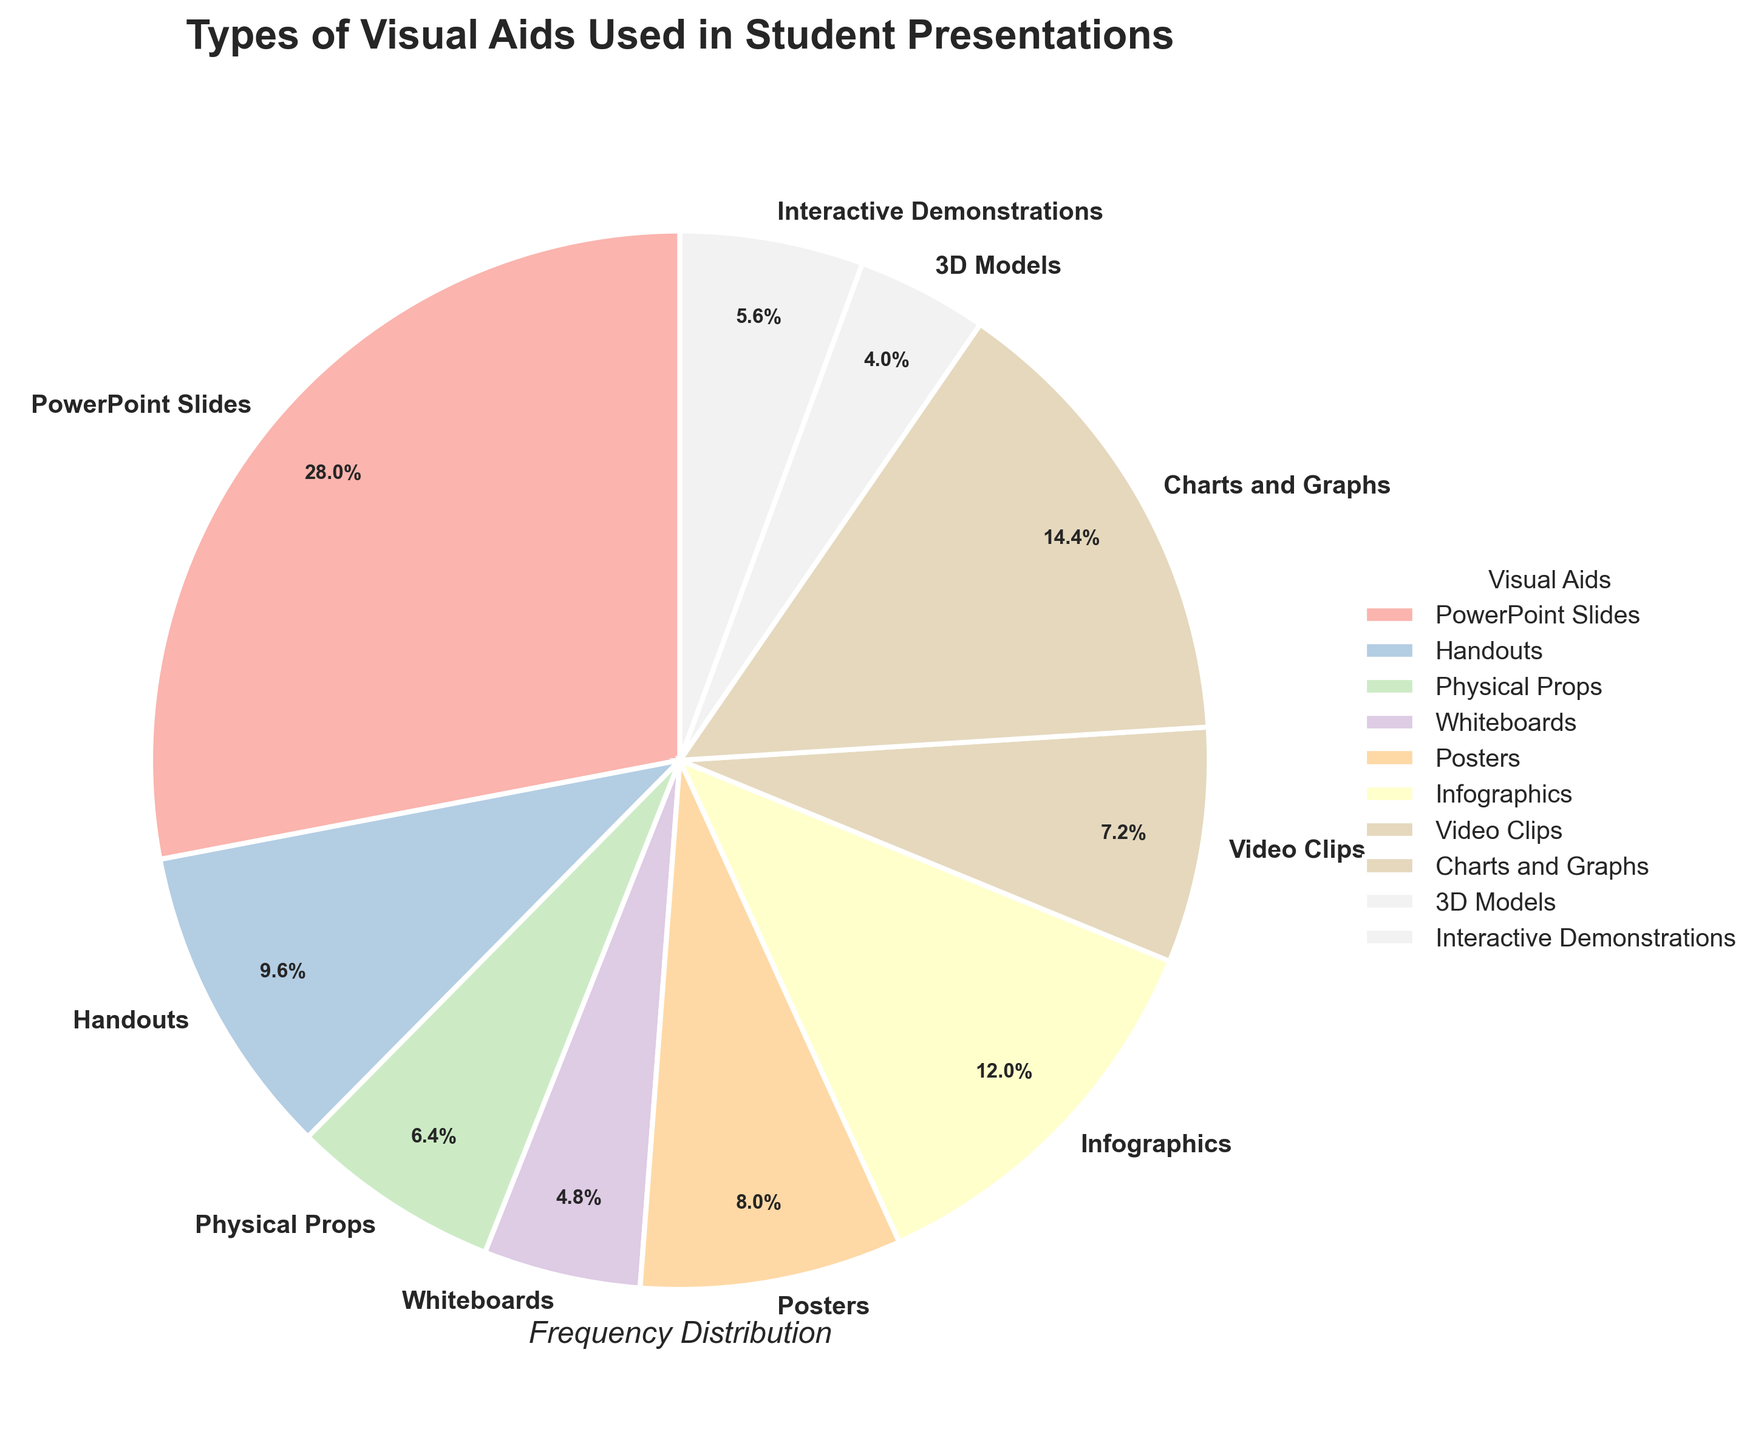Which type of visual aid is used most frequently in student presentations? The slice with the largest proportion represents the most frequently used visual aid. PowerPoint Slides, with 35%, is the largest slice on the chart.
Answer: PowerPoint Slides Which type of visual aid is used least frequently in student presentations? The slice with the smallest proportion represents the least frequently used visual aid. 3D Models, with 5%, is the smallest slice on the chart.
Answer: 3D Models How many types of visual aids are more frequently used than Video Clips? To determine this, compare the frequency percentages of all types with Video Clips, which is 9%. PowerPoint Slides (35%), Infographics (15%), Charts and Graphs (18%), and Handouts (12%) are all used more frequently. There are 4 types in total.
Answer: 4 What is the combined frequency percentage of Handouts and Posters? Add the percentages of Handouts (12%) and Posters (10%). The combined percentage is 12% + 10% = 22%.
Answer: 22% Are Interactive Demonstrations more or less frequently used than Physical Props? Compare the percentages of Interactive Demonstrations (7%) and Physical Props (8%). Interactive Demonstrations are less frequently used than Physical Props.
Answer: Less What is the difference in frequency percentage between the most used and the least used visual aids? Subtract the percentage of the least used visual aid (3D Models, 5%) from the most used visual aid (PowerPoint Slides, 35%). The difference is 35% - 5% = 30%.
Answer: 30% How many types of visual aids have a frequency percentage of 10% or higher? Counting the slices that meet or exceed 10%: PowerPoint Slides (35%), Infographics (15%), Charts and Graphs (18%), Handouts (12%), and Posters (10%) total 5 types.
Answer: 5 What is the average frequency percentage of Whiteboards, Video Clips, and Interactive Demonstrations? Add the percentages and divide by the number of types: (6% + 9% + 7%) / 3 = 22% / 3 = 7.33%.
Answer: 7.33% Which visual aid has a larger percentage, Infographics or Charts and Graphs? Compare the percentages of Infographics (15%) and Charts and Graphs (18%). Charts and Graphs have a larger percentage.
Answer: Charts and Graphs What is the sum of the frequency percentages of the least three frequently used visual aids? Sum the percentages of the least three types: 3D Models (5%), Whiteboards (6%), and Physical Props (8%). Sum is 5% + 6% + 8% = 19%.
Answer: 19% 